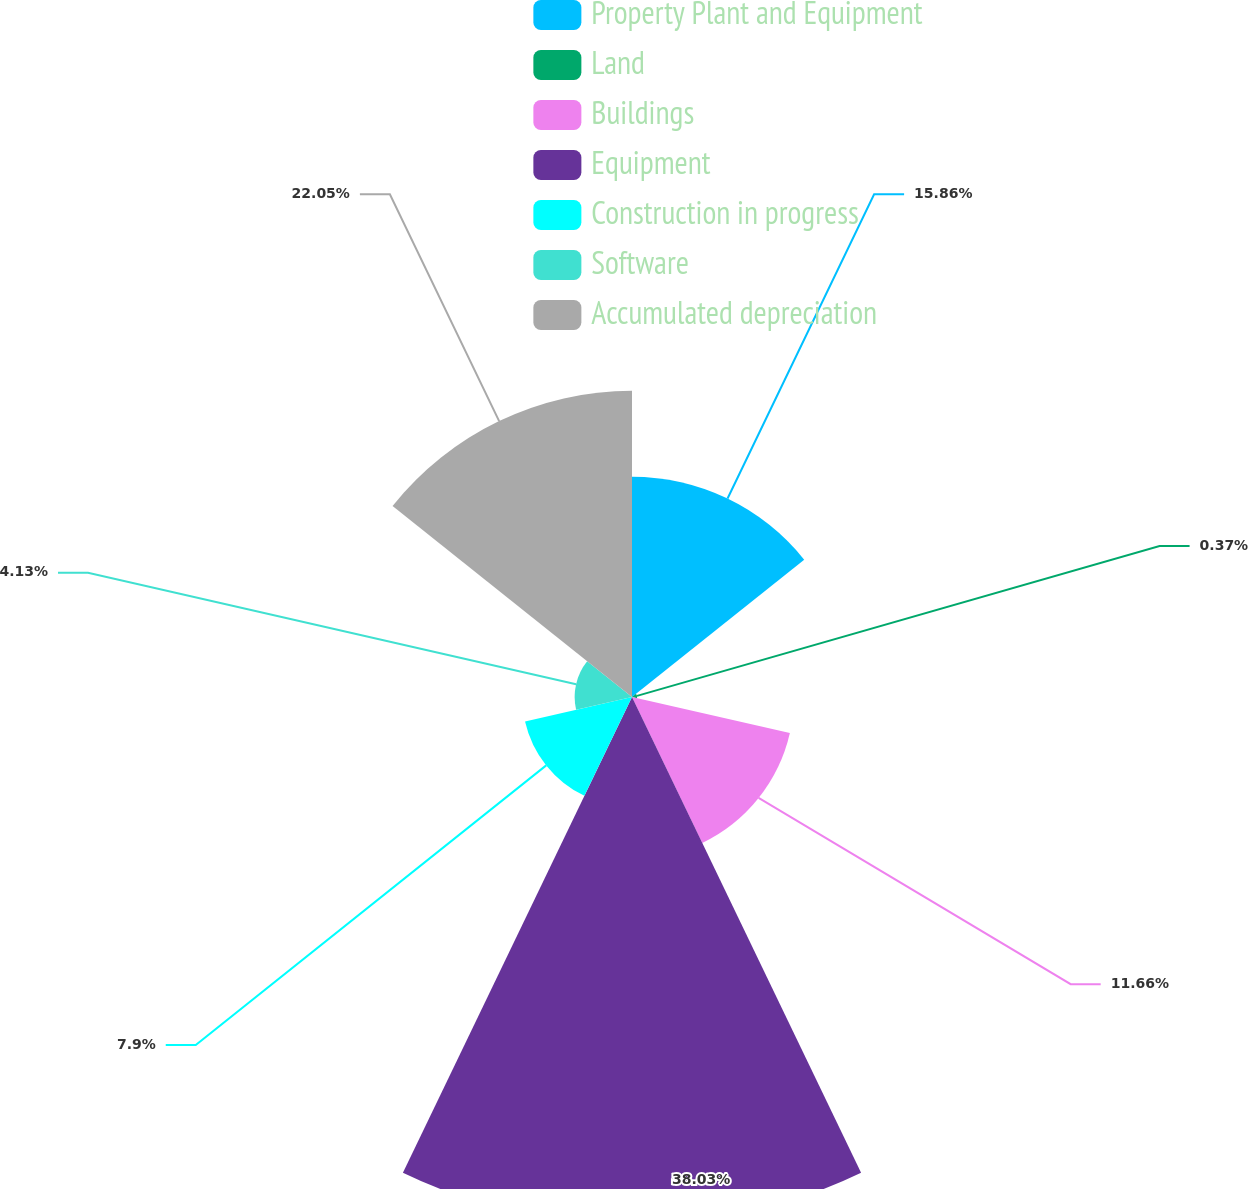Convert chart. <chart><loc_0><loc_0><loc_500><loc_500><pie_chart><fcel>Property Plant and Equipment<fcel>Land<fcel>Buildings<fcel>Equipment<fcel>Construction in progress<fcel>Software<fcel>Accumulated depreciation<nl><fcel>15.86%<fcel>0.37%<fcel>11.66%<fcel>38.02%<fcel>7.9%<fcel>4.13%<fcel>22.05%<nl></chart> 